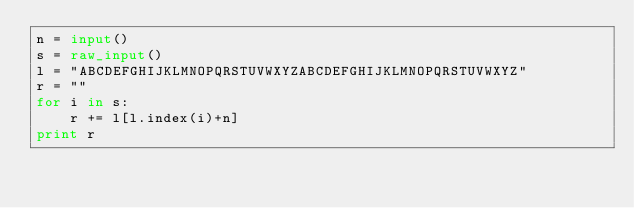Convert code to text. <code><loc_0><loc_0><loc_500><loc_500><_Python_>n = input()
s = raw_input()
l = "ABCDEFGHIJKLMNOPQRSTUVWXYZABCDEFGHIJKLMNOPQRSTUVWXYZ"
r = ""
for i in s:
    r += l[l.index(i)+n]
print r</code> 